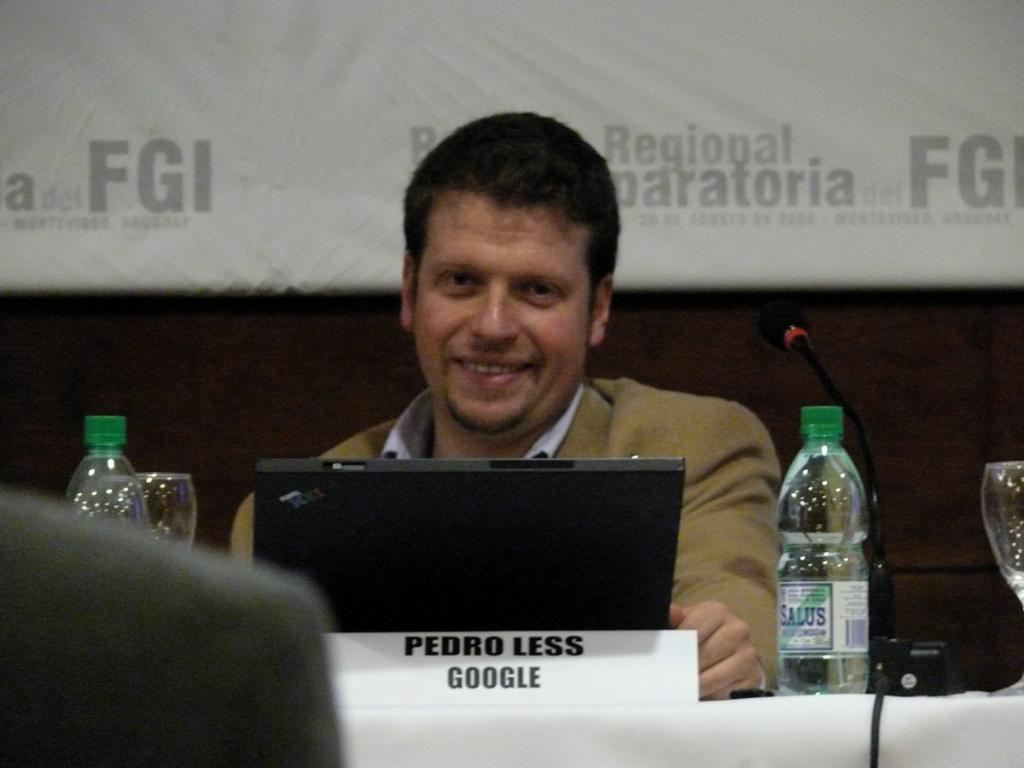Please provide a concise description of this image. In this picture we can see a man sitting on a chair and smiling in front of a table. On the table we can see laptop, water bottles and a board. On the background we can see a board. This is a mike. 